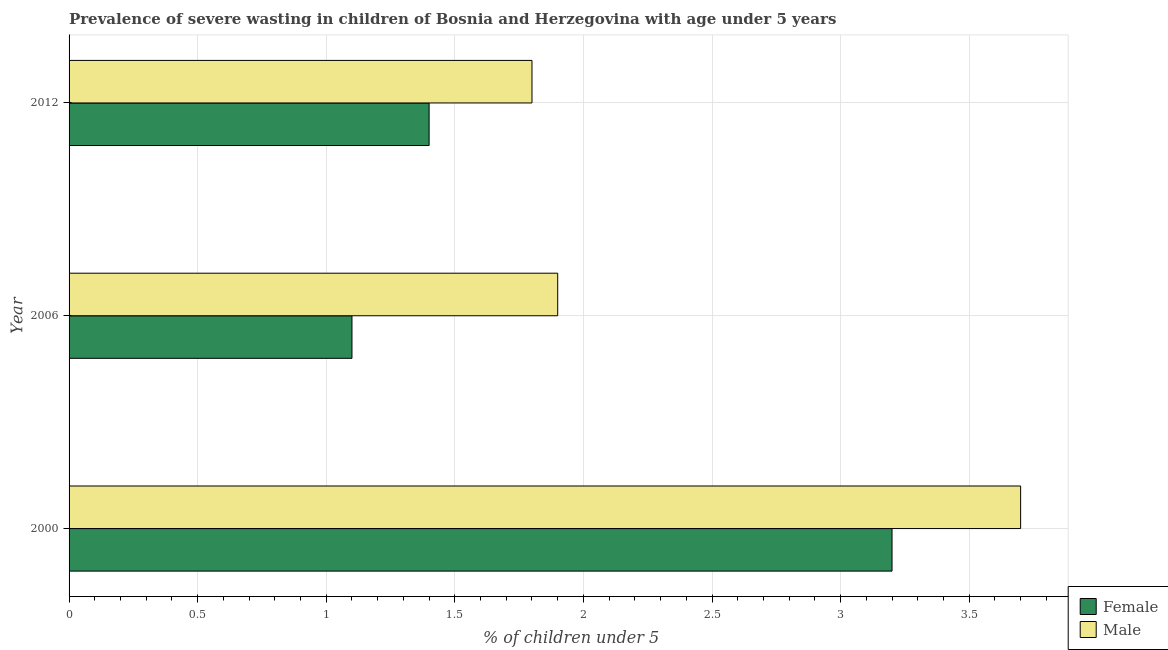How many different coloured bars are there?
Offer a terse response. 2. Are the number of bars on each tick of the Y-axis equal?
Your answer should be compact. Yes. How many bars are there on the 1st tick from the top?
Provide a succinct answer. 2. What is the percentage of undernourished female children in 2006?
Ensure brevity in your answer.  1.1. Across all years, what is the maximum percentage of undernourished female children?
Make the answer very short. 3.2. Across all years, what is the minimum percentage of undernourished male children?
Your answer should be very brief. 1.8. In which year was the percentage of undernourished female children maximum?
Keep it short and to the point. 2000. What is the total percentage of undernourished female children in the graph?
Provide a short and direct response. 5.7. What is the difference between the percentage of undernourished female children in 2006 and the percentage of undernourished male children in 2012?
Provide a succinct answer. -0.7. What is the average percentage of undernourished female children per year?
Provide a succinct answer. 1.9. In how many years, is the percentage of undernourished male children greater than 1.7 %?
Your answer should be very brief. 3. What is the ratio of the percentage of undernourished female children in 2000 to that in 2012?
Offer a very short reply. 2.29. What is the difference between the highest and the lowest percentage of undernourished female children?
Your answer should be very brief. 2.1. In how many years, is the percentage of undernourished male children greater than the average percentage of undernourished male children taken over all years?
Your response must be concise. 1. What does the 2nd bar from the bottom in 2000 represents?
Your answer should be very brief. Male. How many bars are there?
Provide a succinct answer. 6. Are the values on the major ticks of X-axis written in scientific E-notation?
Your response must be concise. No. What is the title of the graph?
Make the answer very short. Prevalence of severe wasting in children of Bosnia and Herzegovina with age under 5 years. What is the label or title of the X-axis?
Your answer should be very brief.  % of children under 5. What is the label or title of the Y-axis?
Your response must be concise. Year. What is the  % of children under 5 in Female in 2000?
Make the answer very short. 3.2. What is the  % of children under 5 in Male in 2000?
Keep it short and to the point. 3.7. What is the  % of children under 5 of Female in 2006?
Your answer should be very brief. 1.1. What is the  % of children under 5 in Male in 2006?
Give a very brief answer. 1.9. What is the  % of children under 5 of Female in 2012?
Provide a short and direct response. 1.4. What is the  % of children under 5 in Male in 2012?
Ensure brevity in your answer.  1.8. Across all years, what is the maximum  % of children under 5 in Female?
Your answer should be very brief. 3.2. Across all years, what is the maximum  % of children under 5 of Male?
Offer a terse response. 3.7. Across all years, what is the minimum  % of children under 5 in Female?
Your response must be concise. 1.1. Across all years, what is the minimum  % of children under 5 of Male?
Offer a very short reply. 1.8. What is the total  % of children under 5 of Female in the graph?
Offer a terse response. 5.7. What is the total  % of children under 5 in Male in the graph?
Your response must be concise. 7.4. What is the difference between the  % of children under 5 of Female in 2000 and that in 2012?
Your answer should be very brief. 1.8. What is the difference between the  % of children under 5 in Male in 2000 and that in 2012?
Provide a short and direct response. 1.9. What is the difference between the  % of children under 5 in Female in 2006 and the  % of children under 5 in Male in 2012?
Make the answer very short. -0.7. What is the average  % of children under 5 in Male per year?
Make the answer very short. 2.47. What is the ratio of the  % of children under 5 in Female in 2000 to that in 2006?
Provide a succinct answer. 2.91. What is the ratio of the  % of children under 5 in Male in 2000 to that in 2006?
Your answer should be very brief. 1.95. What is the ratio of the  % of children under 5 of Female in 2000 to that in 2012?
Keep it short and to the point. 2.29. What is the ratio of the  % of children under 5 of Male in 2000 to that in 2012?
Your answer should be very brief. 2.06. What is the ratio of the  % of children under 5 of Female in 2006 to that in 2012?
Keep it short and to the point. 0.79. What is the ratio of the  % of children under 5 of Male in 2006 to that in 2012?
Keep it short and to the point. 1.06. What is the difference between the highest and the second highest  % of children under 5 in Male?
Your response must be concise. 1.8. What is the difference between the highest and the lowest  % of children under 5 in Male?
Your response must be concise. 1.9. 